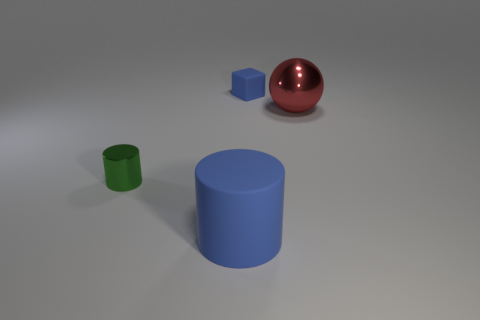Add 1 small cyan balls. How many objects exist? 5 Subtract all blue cylinders. How many cylinders are left? 1 Subtract all cubes. How many objects are left? 3 Subtract all cyan cylinders. Subtract all yellow balls. How many cylinders are left? 2 Subtract all blue balls. How many blue cylinders are left? 1 Subtract all large red objects. Subtract all rubber things. How many objects are left? 1 Add 2 big red spheres. How many big red spheres are left? 3 Add 4 small brown cylinders. How many small brown cylinders exist? 4 Subtract 0 gray spheres. How many objects are left? 4 